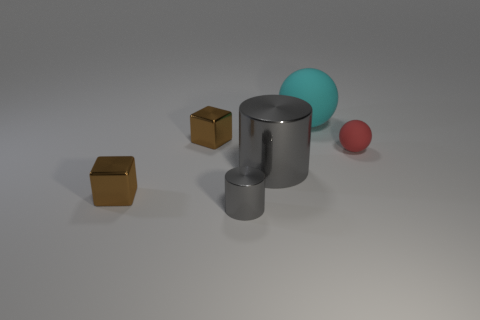Are the cyan object and the tiny cube that is behind the red ball made of the same material?
Your answer should be compact. No. How many objects are cylinders in front of the red matte sphere or small matte things that are right of the large metal object?
Your answer should be very brief. 3. How many other things are the same color as the tiny sphere?
Offer a terse response. 0. Are there fewer tiny red rubber things that are to the left of the tiny red thing than gray cylinders that are in front of the cyan matte thing?
Your answer should be very brief. Yes. How many things are there?
Your response must be concise. 6. What is the material of the big cyan object that is the same shape as the small red rubber thing?
Ensure brevity in your answer.  Rubber. Is the number of big gray things behind the tiny red rubber ball less than the number of purple cubes?
Provide a short and direct response. No. There is a cyan thing to the right of the large gray object; is its shape the same as the small red matte thing?
Offer a terse response. Yes. Is there anything else that is the same color as the tiny cylinder?
Ensure brevity in your answer.  Yes. What size is the cyan thing that is the same material as the red sphere?
Offer a terse response. Large. 